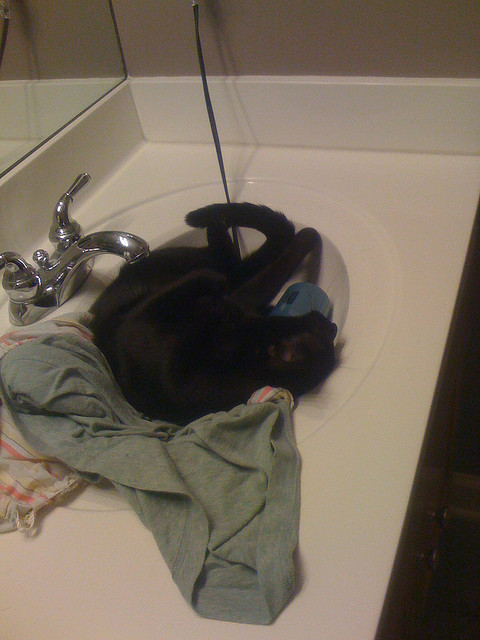Create a short story about the cat in the sink. One sunny afternoon, a curious black cat named Midnight found itself climbing into the bathroom sink, seeking a cozy spot to relax. Midnight had always been fascinated by water and enjoyed playing in the sink whenever the tap was slightly dripping. Today, as it settled down on a pile of freshly washed clothes and towels, the sink felt unusually warm and comfortable, almost as if it was welcoming the cat for a special rest. As Midnight curled up and closed its eyes, it began to dream of adventures in a magical land filled with warm, sunny fields and inviting shadowy nooks. It was a perfect place for a catnap - safe, serene, and utterly charming. 